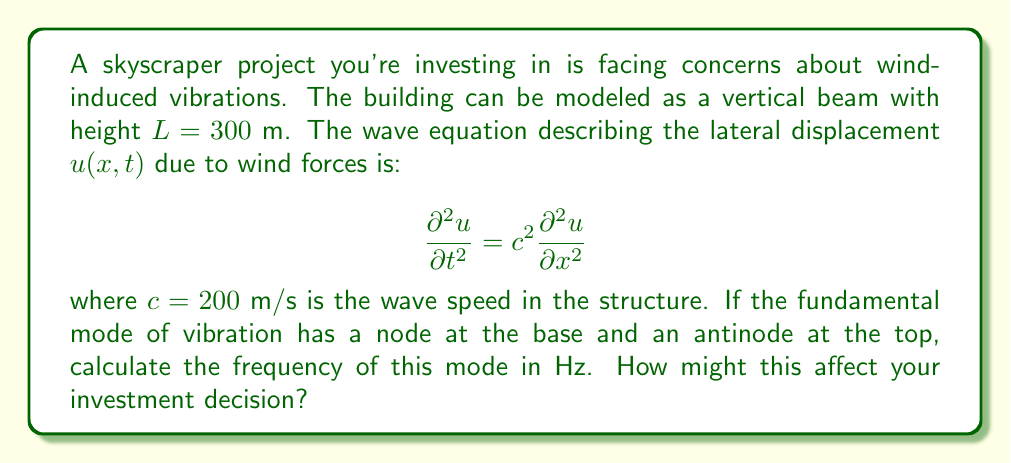Solve this math problem. To solve this problem, we'll follow these steps:

1) The general solution for the wave equation in this case is:
   $$u(x,t) = [A \sin(kx) + B \cos(kx)][C \sin(\omega t) + D \cos(\omega t)]$$
   where $k$ is the wave number and $\omega$ is the angular frequency.

2) The boundary conditions are:
   - At $x = 0$ (base): $u(0,t) = 0$ (node)
   - At $x = L$ (top): $\frac{\partial u}{\partial x}(L,t) = 0$ (antinode)

3) Applying the first boundary condition:
   $$u(0,t) = 0 \implies B = 0$$

4) The solution becomes:
   $$u(x,t) = A \sin(kx)[C \sin(\omega t) + D \cos(\omega t)]$$

5) Applying the second boundary condition:
   $$\frac{\partial u}{\partial x}(L,t) = 0 \implies \cos(kL) = 0$$

6) This is satisfied when:
   $$kL = \frac{\pi}{2} + n\pi, \quad n = 0, 1, 2, ...$$

7) For the fundamental mode, $n = 0$, so:
   $$k = \frac{\pi}{2L} = \frac{\pi}{2(300)} = \frac{\pi}{600}$$

8) The relationship between $k$, $\omega$, and $c$ is:
   $$\omega = ck$$

9) Substituting the values:
   $$\omega = 200 \cdot \frac{\pi}{600} = \frac{\pi}{3}$$

10) Convert angular frequency to frequency in Hz:
    $$f = \frac{\omega}{2\pi} = \frac{\pi/3}{2\pi} = \frac{1}{6} \approx 0.167 \text{ Hz}$$

This frequency could affect the investment decision as it's in the range where humans are sensitive to motion (0.1 - 1 Hz). It may cause discomfort to occupants, potentially reducing the building's value or requiring additional damping systems, impacting the project's profitability.
Answer: 0.167 Hz 